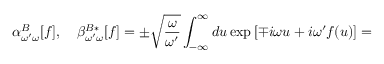<formula> <loc_0><loc_0><loc_500><loc_500>\alpha _ { \omega ^ { \prime } \omega } ^ { B } [ f ] , \quad \beta _ { \omega ^ { \prime } \omega } ^ { B * } [ f ] = \pm \sqrt { \frac { \omega } { \omega ^ { \prime } } } \int _ { - \infty } ^ { \infty } d u \exp \, [ \mp i \omega u + i \omega ^ { \prime } f ( u ) ] =</formula> 